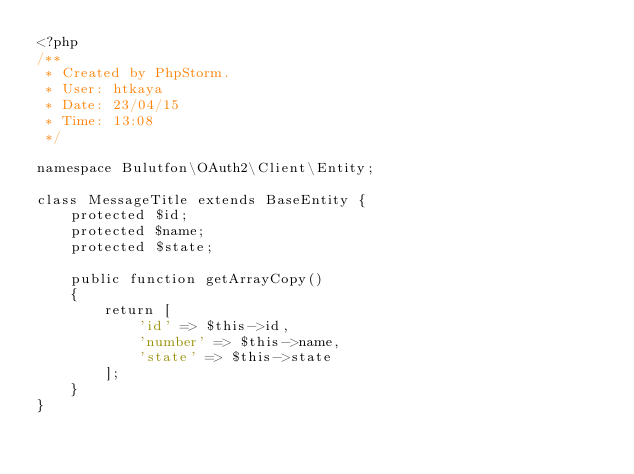<code> <loc_0><loc_0><loc_500><loc_500><_PHP_><?php
/**
 * Created by PhpStorm.
 * User: htkaya
 * Date: 23/04/15
 * Time: 13:08
 */

namespace Bulutfon\OAuth2\Client\Entity;

class MessageTitle extends BaseEntity {
    protected $id;
    protected $name;
    protected $state;

    public function getArrayCopy()
    {
        return [
            'id' => $this->id,
            'number' => $this->name,
            'state' => $this->state
        ];
    }
}</code> 